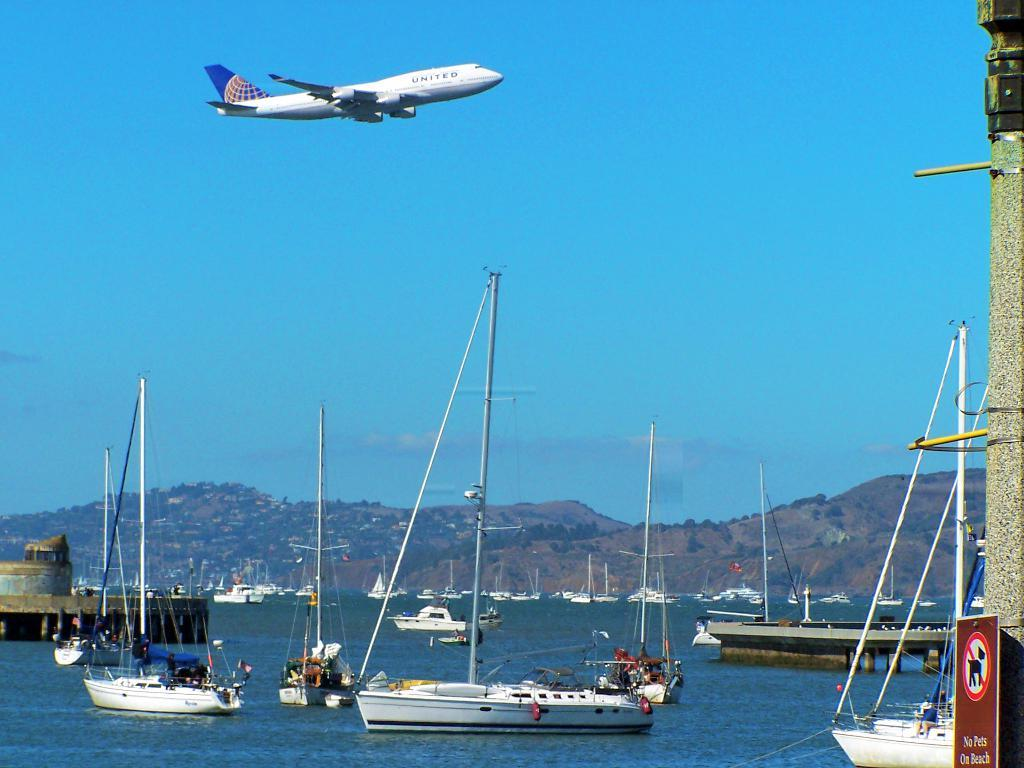<image>
Create a compact narrative representing the image presented. A United airlines plane flies over a water full of boats with sails down. 